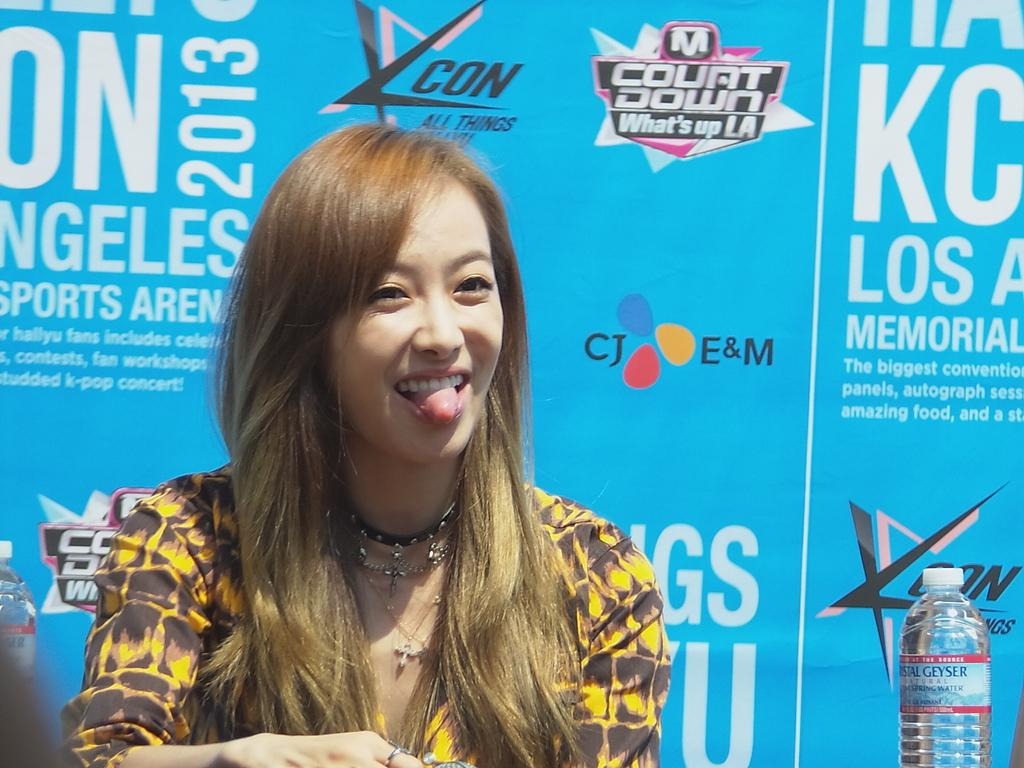What is the main feature of the image? There is a stage in the image. What is happening on the stage? A girl is sitting on a chair on the stage. What is the girl wearing? The girl is wearing a yellow dress. What is the girl's expression? The girl is laughing. What can be seen behind the girl? There is a wall behind the girl. What type of insect is crawling on the sheet in the image? There is no sheet or insect present in the image. 